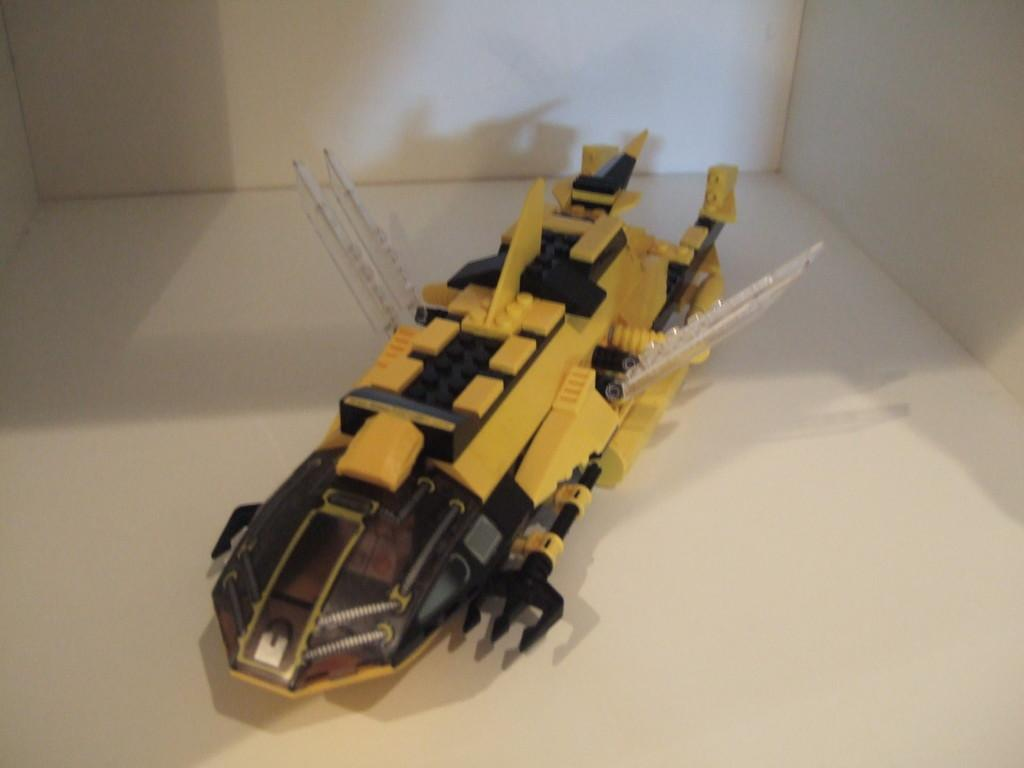Who is the main subject in the image? There is a person (presumably the speaker) in the image. What is the person standing on? The person is standing on a white platform. What can be seen in the background of the image? There is a wall in the background of the image. What type of silver object is visible on the platform in the image? There is no silver object present on the platform in the image. 